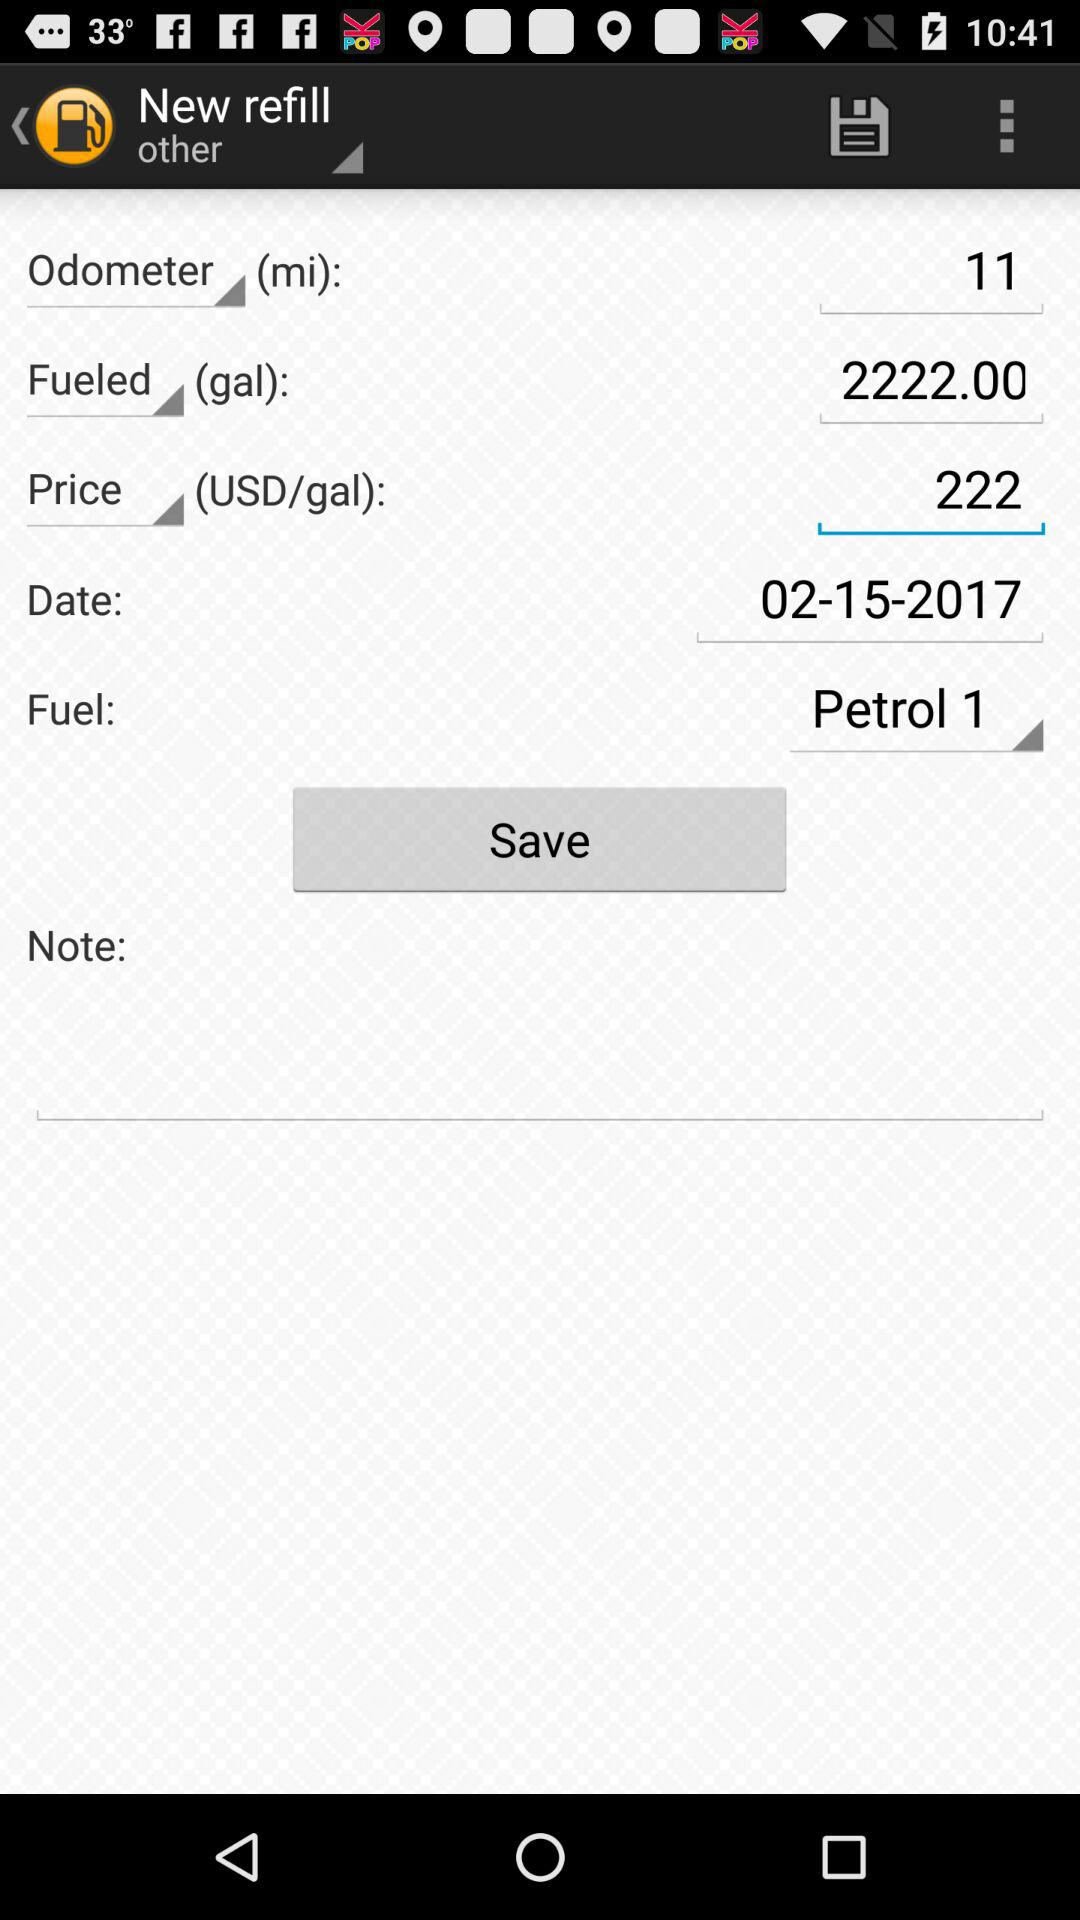What is the price of fuel? The price of fuel is 222 USD per gallon. 